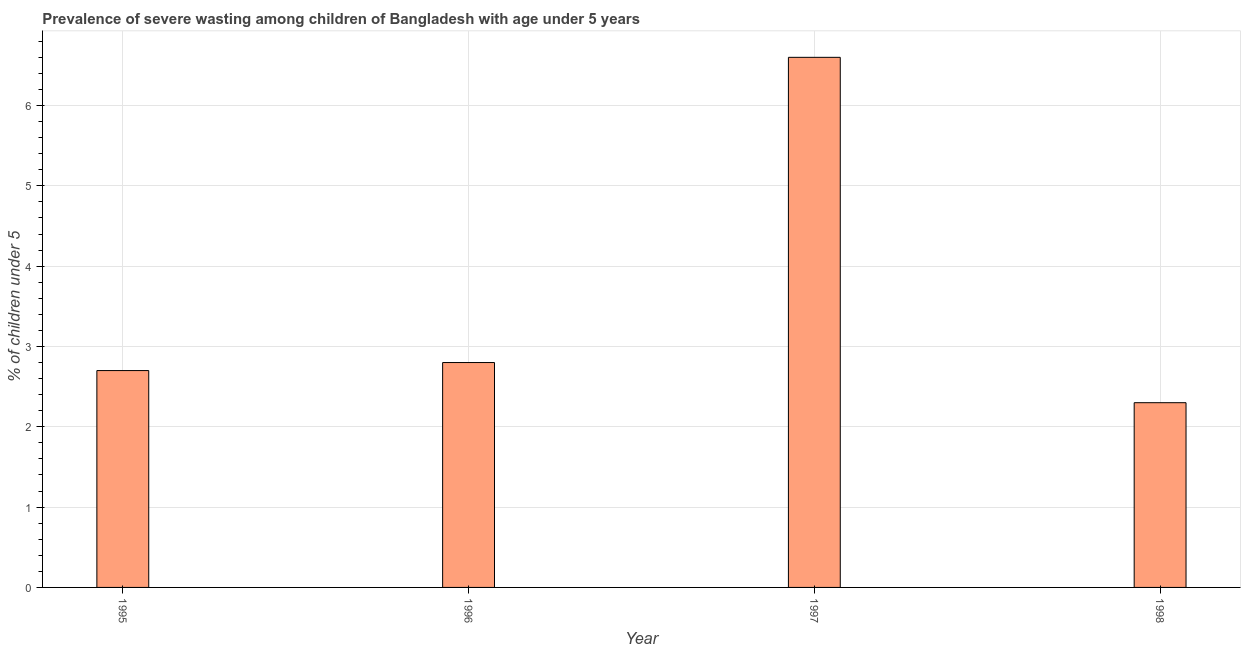Does the graph contain any zero values?
Your response must be concise. No. Does the graph contain grids?
Provide a short and direct response. Yes. What is the title of the graph?
Give a very brief answer. Prevalence of severe wasting among children of Bangladesh with age under 5 years. What is the label or title of the X-axis?
Offer a terse response. Year. What is the label or title of the Y-axis?
Your answer should be compact.  % of children under 5. What is the prevalence of severe wasting in 1998?
Offer a very short reply. 2.3. Across all years, what is the maximum prevalence of severe wasting?
Offer a very short reply. 6.6. Across all years, what is the minimum prevalence of severe wasting?
Make the answer very short. 2.3. In which year was the prevalence of severe wasting minimum?
Keep it short and to the point. 1998. What is the sum of the prevalence of severe wasting?
Your answer should be very brief. 14.4. What is the average prevalence of severe wasting per year?
Offer a very short reply. 3.6. What is the median prevalence of severe wasting?
Offer a very short reply. 2.75. Do a majority of the years between 1995 and 1997 (inclusive) have prevalence of severe wasting greater than 5.2 %?
Keep it short and to the point. No. What is the ratio of the prevalence of severe wasting in 1995 to that in 1996?
Keep it short and to the point. 0.96. Is the prevalence of severe wasting in 1996 less than that in 1997?
Ensure brevity in your answer.  Yes. Is the sum of the prevalence of severe wasting in 1996 and 1997 greater than the maximum prevalence of severe wasting across all years?
Your answer should be compact. Yes. What is the difference between the highest and the lowest prevalence of severe wasting?
Provide a succinct answer. 4.3. How many bars are there?
Offer a terse response. 4. Are all the bars in the graph horizontal?
Offer a very short reply. No. What is the difference between two consecutive major ticks on the Y-axis?
Keep it short and to the point. 1. What is the  % of children under 5 in 1995?
Offer a terse response. 2.7. What is the  % of children under 5 in 1996?
Your answer should be very brief. 2.8. What is the  % of children under 5 in 1997?
Offer a terse response. 6.6. What is the  % of children under 5 in 1998?
Provide a short and direct response. 2.3. What is the difference between the  % of children under 5 in 1995 and 1996?
Ensure brevity in your answer.  -0.1. What is the difference between the  % of children under 5 in 1995 and 1997?
Offer a very short reply. -3.9. What is the difference between the  % of children under 5 in 1997 and 1998?
Ensure brevity in your answer.  4.3. What is the ratio of the  % of children under 5 in 1995 to that in 1996?
Provide a short and direct response. 0.96. What is the ratio of the  % of children under 5 in 1995 to that in 1997?
Give a very brief answer. 0.41. What is the ratio of the  % of children under 5 in 1995 to that in 1998?
Offer a very short reply. 1.17. What is the ratio of the  % of children under 5 in 1996 to that in 1997?
Offer a terse response. 0.42. What is the ratio of the  % of children under 5 in 1996 to that in 1998?
Provide a short and direct response. 1.22. What is the ratio of the  % of children under 5 in 1997 to that in 1998?
Provide a short and direct response. 2.87. 